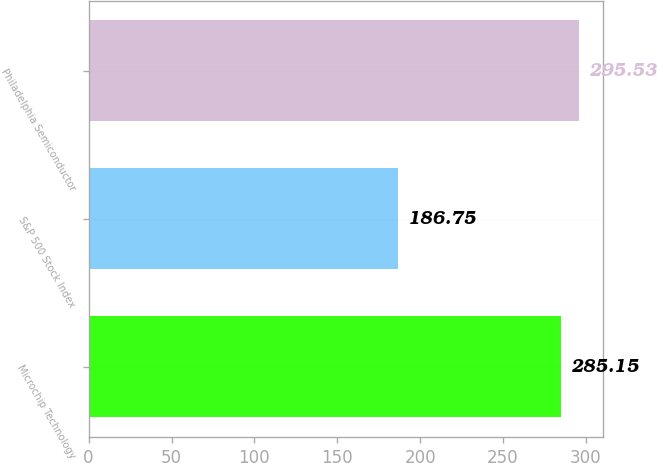Convert chart to OTSL. <chart><loc_0><loc_0><loc_500><loc_500><bar_chart><fcel>Microchip Technology<fcel>S&P 500 Stock Index<fcel>Philadelphia Semiconductor<nl><fcel>285.15<fcel>186.75<fcel>295.53<nl></chart> 